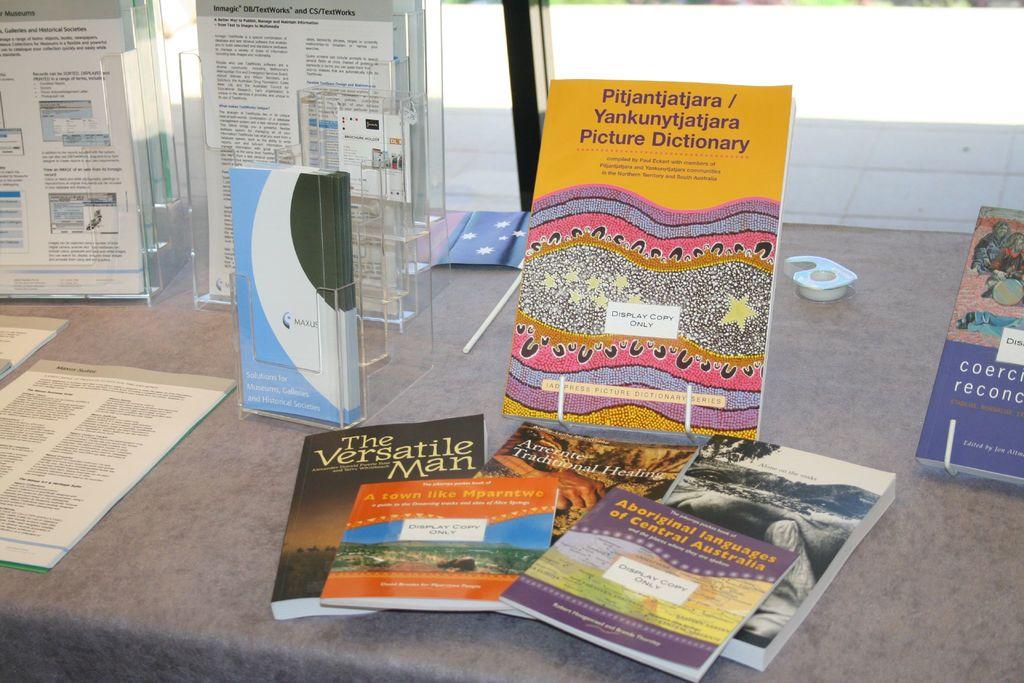What is the title of the black magazine?
Your response must be concise. The versatile man. 